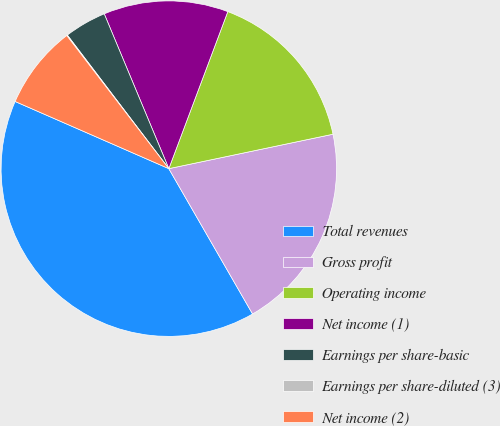<chart> <loc_0><loc_0><loc_500><loc_500><pie_chart><fcel>Total revenues<fcel>Gross profit<fcel>Operating income<fcel>Net income (1)<fcel>Earnings per share-basic<fcel>Earnings per share-diluted (3)<fcel>Net income (2)<nl><fcel>39.88%<fcel>19.97%<fcel>15.99%<fcel>12.01%<fcel>4.05%<fcel>0.07%<fcel>8.03%<nl></chart> 